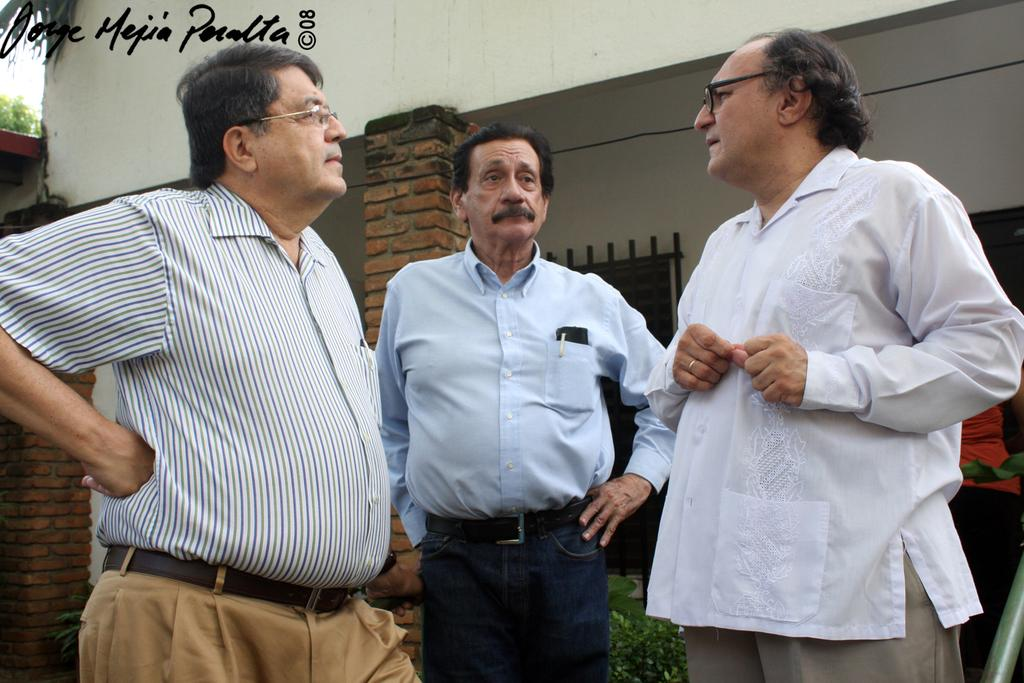What can be seen in the image? There are people standing in the image. What architectural features are visible in the background? There are pillars, windows, and a wall in the background of the image. What type of vegetation is present in the background? There are plants in the background of the image. Are there any other people visible in the image? Yes, there is a person in the background of the image. What objects can be seen in the background? There is a rod, a wire, and text visible in the top left side of the image. What is the number of pumps visible in the image? There are no pumps visible in the image. What stage of development is the project in, as seen in the image? The image does not provide any information about the development stage of a project. 